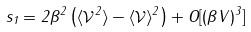<formula> <loc_0><loc_0><loc_500><loc_500>s _ { 1 } = 2 \beta ^ { 2 } \left ( \langle { \mathcal { V } ^ { 2 } } \rangle - \langle { \mathcal { V } } \rangle ^ { 2 } \right ) + O [ ( \beta V ) ^ { 3 } ]</formula> 